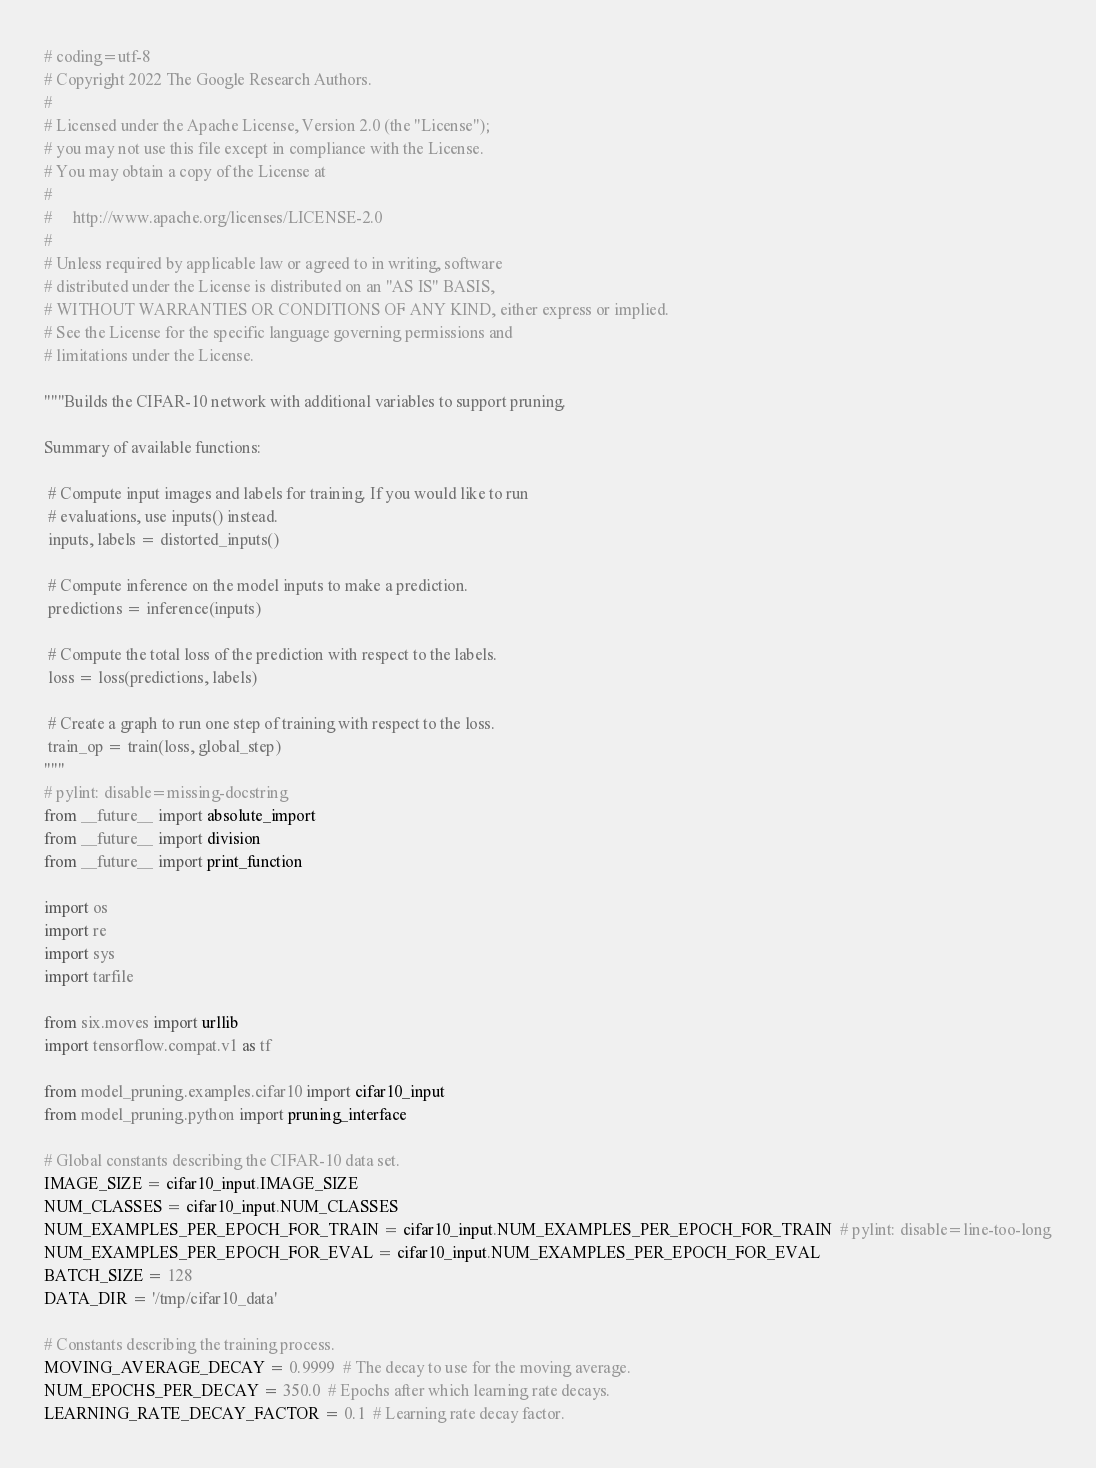<code> <loc_0><loc_0><loc_500><loc_500><_Python_># coding=utf-8
# Copyright 2022 The Google Research Authors.
#
# Licensed under the Apache License, Version 2.0 (the "License");
# you may not use this file except in compliance with the License.
# You may obtain a copy of the License at
#
#     http://www.apache.org/licenses/LICENSE-2.0
#
# Unless required by applicable law or agreed to in writing, software
# distributed under the License is distributed on an "AS IS" BASIS,
# WITHOUT WARRANTIES OR CONDITIONS OF ANY KIND, either express or implied.
# See the License for the specific language governing permissions and
# limitations under the License.

"""Builds the CIFAR-10 network with additional variables to support pruning.

Summary of available functions:

 # Compute input images and labels for training. If you would like to run
 # evaluations, use inputs() instead.
 inputs, labels = distorted_inputs()

 # Compute inference on the model inputs to make a prediction.
 predictions = inference(inputs)

 # Compute the total loss of the prediction with respect to the labels.
 loss = loss(predictions, labels)

 # Create a graph to run one step of training with respect to the loss.
 train_op = train(loss, global_step)
"""
# pylint: disable=missing-docstring
from __future__ import absolute_import
from __future__ import division
from __future__ import print_function

import os
import re
import sys
import tarfile

from six.moves import urllib
import tensorflow.compat.v1 as tf

from model_pruning.examples.cifar10 import cifar10_input
from model_pruning.python import pruning_interface

# Global constants describing the CIFAR-10 data set.
IMAGE_SIZE = cifar10_input.IMAGE_SIZE
NUM_CLASSES = cifar10_input.NUM_CLASSES
NUM_EXAMPLES_PER_EPOCH_FOR_TRAIN = cifar10_input.NUM_EXAMPLES_PER_EPOCH_FOR_TRAIN  # pylint: disable=line-too-long
NUM_EXAMPLES_PER_EPOCH_FOR_EVAL = cifar10_input.NUM_EXAMPLES_PER_EPOCH_FOR_EVAL
BATCH_SIZE = 128
DATA_DIR = '/tmp/cifar10_data'

# Constants describing the training process.
MOVING_AVERAGE_DECAY = 0.9999  # The decay to use for the moving average.
NUM_EPOCHS_PER_DECAY = 350.0  # Epochs after which learning rate decays.
LEARNING_RATE_DECAY_FACTOR = 0.1  # Learning rate decay factor.</code> 